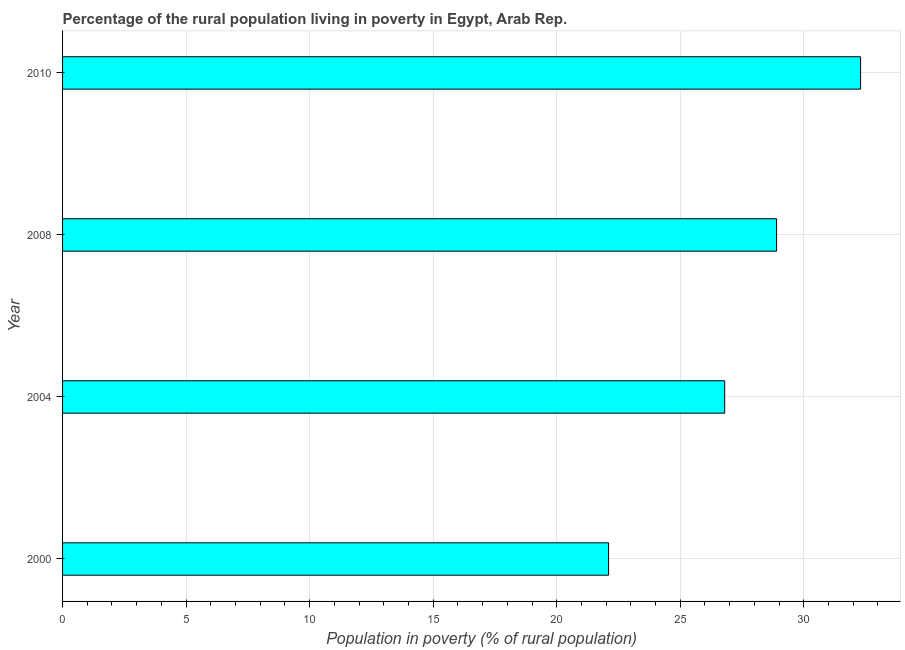Does the graph contain grids?
Ensure brevity in your answer.  Yes. What is the title of the graph?
Provide a succinct answer. Percentage of the rural population living in poverty in Egypt, Arab Rep. What is the label or title of the X-axis?
Keep it short and to the point. Population in poverty (% of rural population). What is the percentage of rural population living below poverty line in 2004?
Your answer should be compact. 26.8. Across all years, what is the maximum percentage of rural population living below poverty line?
Ensure brevity in your answer.  32.3. Across all years, what is the minimum percentage of rural population living below poverty line?
Offer a terse response. 22.1. In which year was the percentage of rural population living below poverty line maximum?
Keep it short and to the point. 2010. What is the sum of the percentage of rural population living below poverty line?
Keep it short and to the point. 110.1. What is the average percentage of rural population living below poverty line per year?
Make the answer very short. 27.52. What is the median percentage of rural population living below poverty line?
Give a very brief answer. 27.85. What is the ratio of the percentage of rural population living below poverty line in 2004 to that in 2008?
Your answer should be compact. 0.93. Is the sum of the percentage of rural population living below poverty line in 2000 and 2004 greater than the maximum percentage of rural population living below poverty line across all years?
Offer a terse response. Yes. What is the difference between the highest and the lowest percentage of rural population living below poverty line?
Give a very brief answer. 10.2. In how many years, is the percentage of rural population living below poverty line greater than the average percentage of rural population living below poverty line taken over all years?
Provide a short and direct response. 2. Are all the bars in the graph horizontal?
Keep it short and to the point. Yes. How many years are there in the graph?
Ensure brevity in your answer.  4. What is the difference between two consecutive major ticks on the X-axis?
Offer a very short reply. 5. Are the values on the major ticks of X-axis written in scientific E-notation?
Provide a succinct answer. No. What is the Population in poverty (% of rural population) of 2000?
Give a very brief answer. 22.1. What is the Population in poverty (% of rural population) in 2004?
Provide a short and direct response. 26.8. What is the Population in poverty (% of rural population) of 2008?
Provide a short and direct response. 28.9. What is the Population in poverty (% of rural population) of 2010?
Provide a succinct answer. 32.3. What is the difference between the Population in poverty (% of rural population) in 2000 and 2008?
Your answer should be very brief. -6.8. What is the difference between the Population in poverty (% of rural population) in 2000 and 2010?
Offer a very short reply. -10.2. What is the difference between the Population in poverty (% of rural population) in 2004 and 2008?
Offer a very short reply. -2.1. What is the ratio of the Population in poverty (% of rural population) in 2000 to that in 2004?
Provide a short and direct response. 0.82. What is the ratio of the Population in poverty (% of rural population) in 2000 to that in 2008?
Your response must be concise. 0.77. What is the ratio of the Population in poverty (% of rural population) in 2000 to that in 2010?
Offer a terse response. 0.68. What is the ratio of the Population in poverty (% of rural population) in 2004 to that in 2008?
Offer a very short reply. 0.93. What is the ratio of the Population in poverty (% of rural population) in 2004 to that in 2010?
Provide a short and direct response. 0.83. What is the ratio of the Population in poverty (% of rural population) in 2008 to that in 2010?
Offer a terse response. 0.9. 